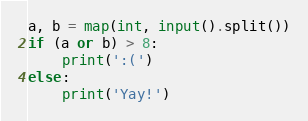<code> <loc_0><loc_0><loc_500><loc_500><_Python_>a, b = map(int, input().split())
if (a or b) > 8:
    print(':(')
else:
    print('Yay!')</code> 